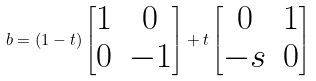Convert formula to latex. <formula><loc_0><loc_0><loc_500><loc_500>b = ( 1 - t ) \begin{bmatrix} 1 & 0 \\ 0 & - 1 \end{bmatrix} + t \begin{bmatrix} 0 & 1 \\ - s & 0 \end{bmatrix}</formula> 